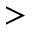<formula> <loc_0><loc_0><loc_500><loc_500>></formula> 